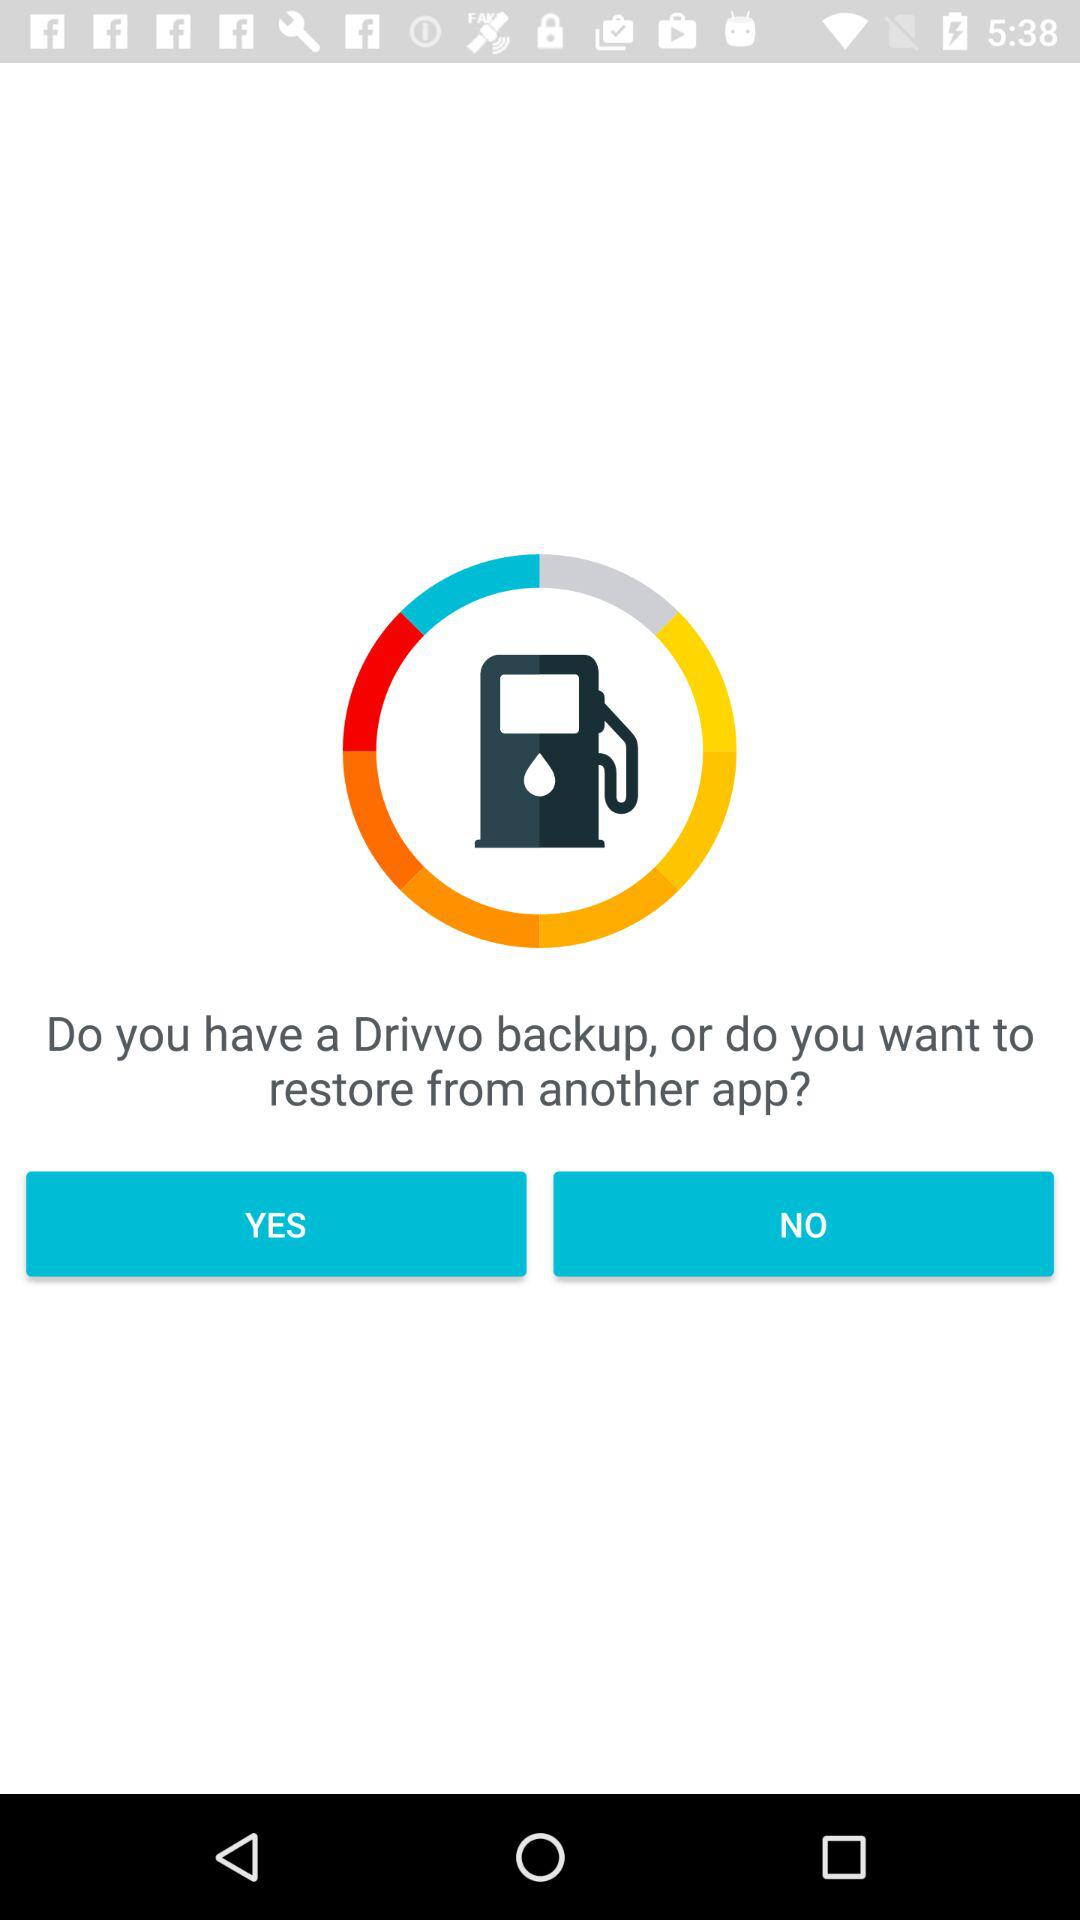What is the application name? The application name is "Drivvo". 